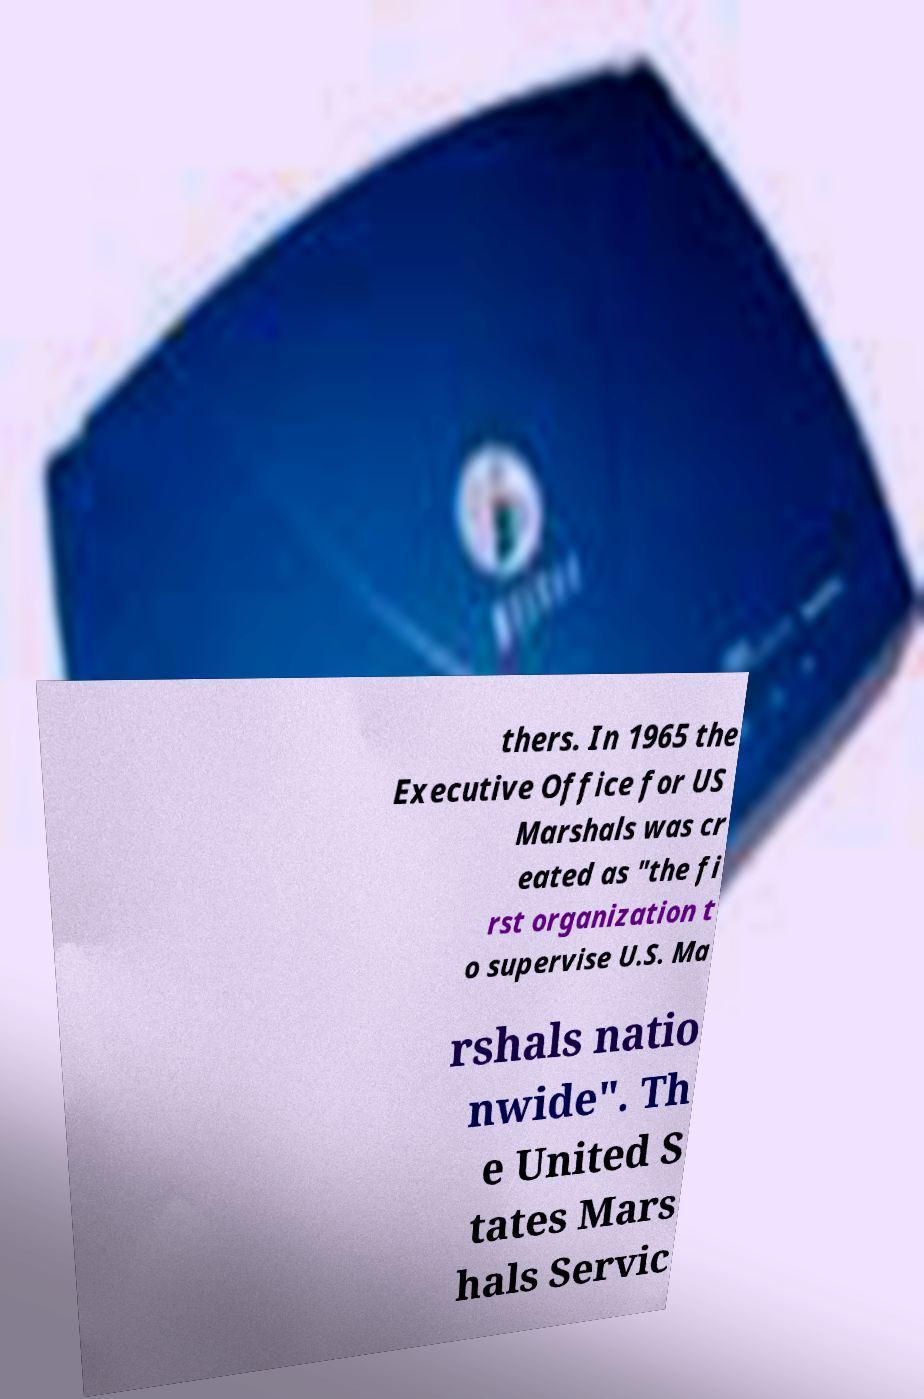I need the written content from this picture converted into text. Can you do that? thers. In 1965 the Executive Office for US Marshals was cr eated as "the fi rst organization t o supervise U.S. Ma rshals natio nwide". Th e United S tates Mars hals Servic 